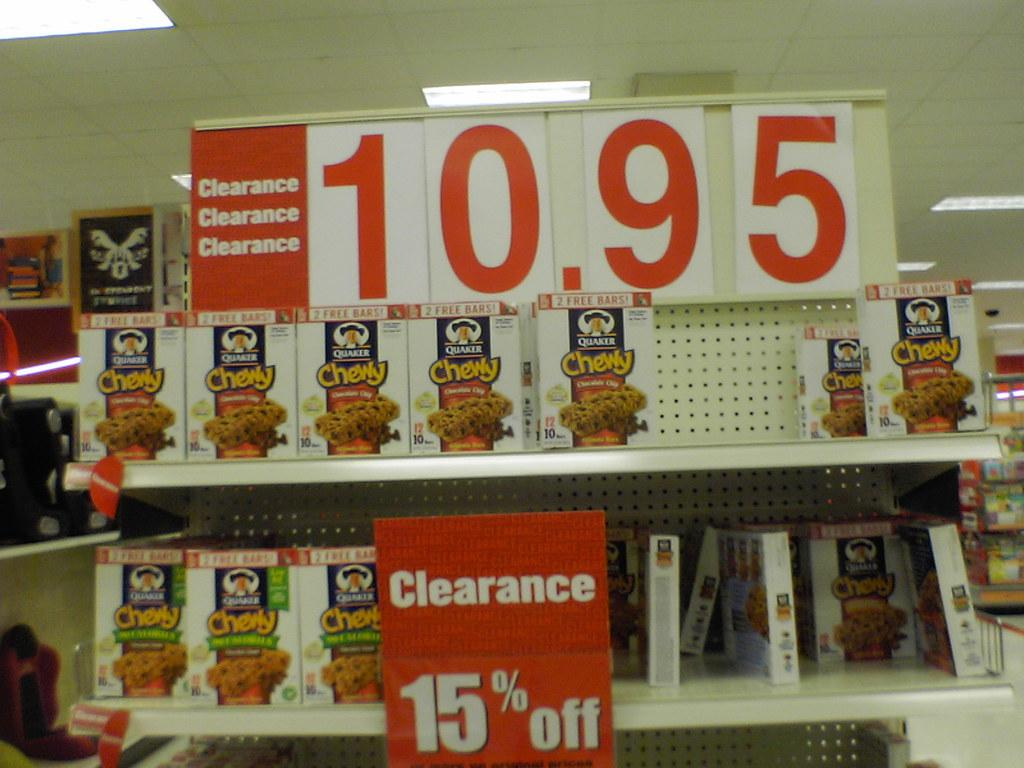What is the main structure in the image? There is a rack in the image. What is stored on the rack? Cartons are placed in the rack. What other objects can be seen in the image? There are boards in the image. What is visible at the top of the image? Lights are visible at the top of the image. How many cows are present in the image? There are no cows present in the image. What hand gesture is being made by the person in the image? There is no person present in the image, so no hand gestures can be observed. 